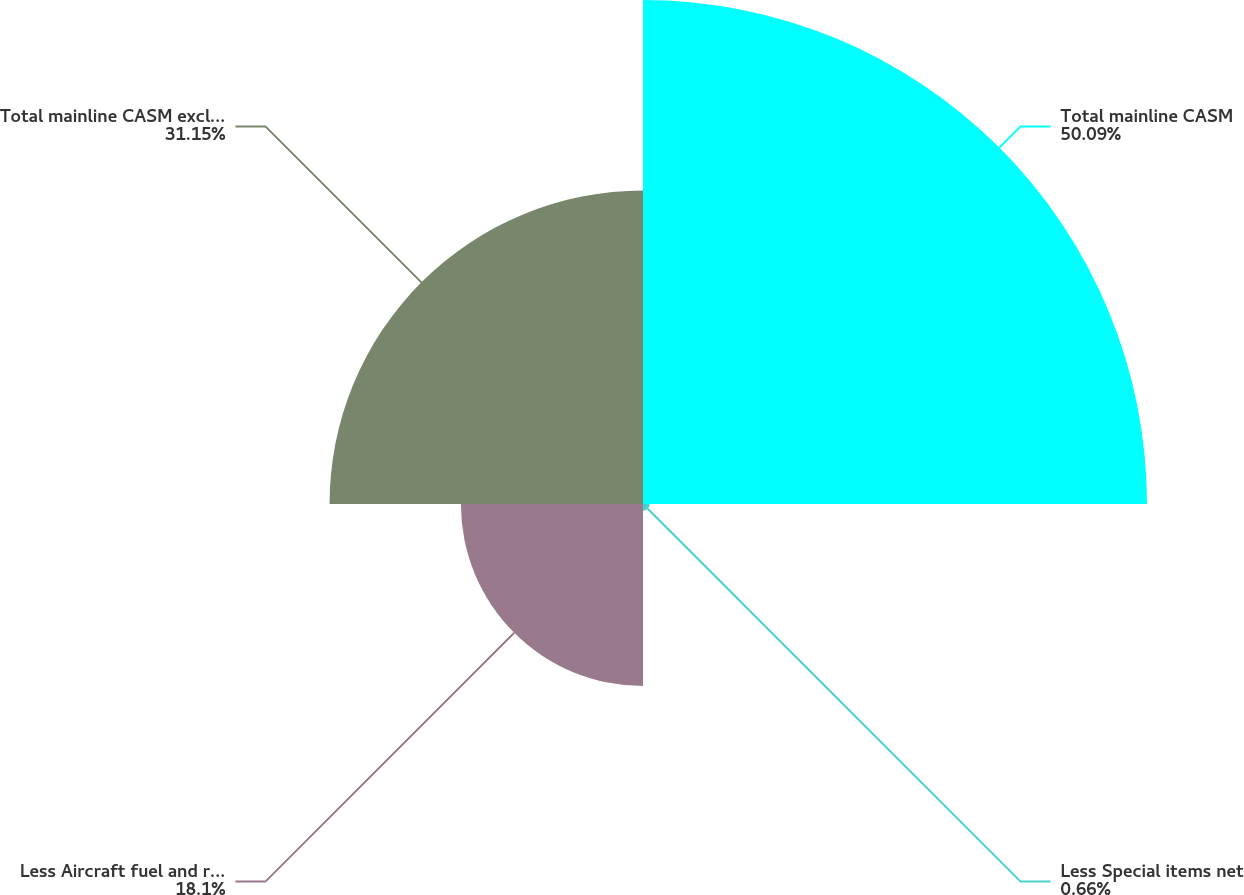Convert chart. <chart><loc_0><loc_0><loc_500><loc_500><pie_chart><fcel>Total mainline CASM<fcel>Less Special items net<fcel>Less Aircraft fuel and related<fcel>Total mainline CASM excluding<nl><fcel>50.09%<fcel>0.66%<fcel>18.1%<fcel>31.15%<nl></chart> 